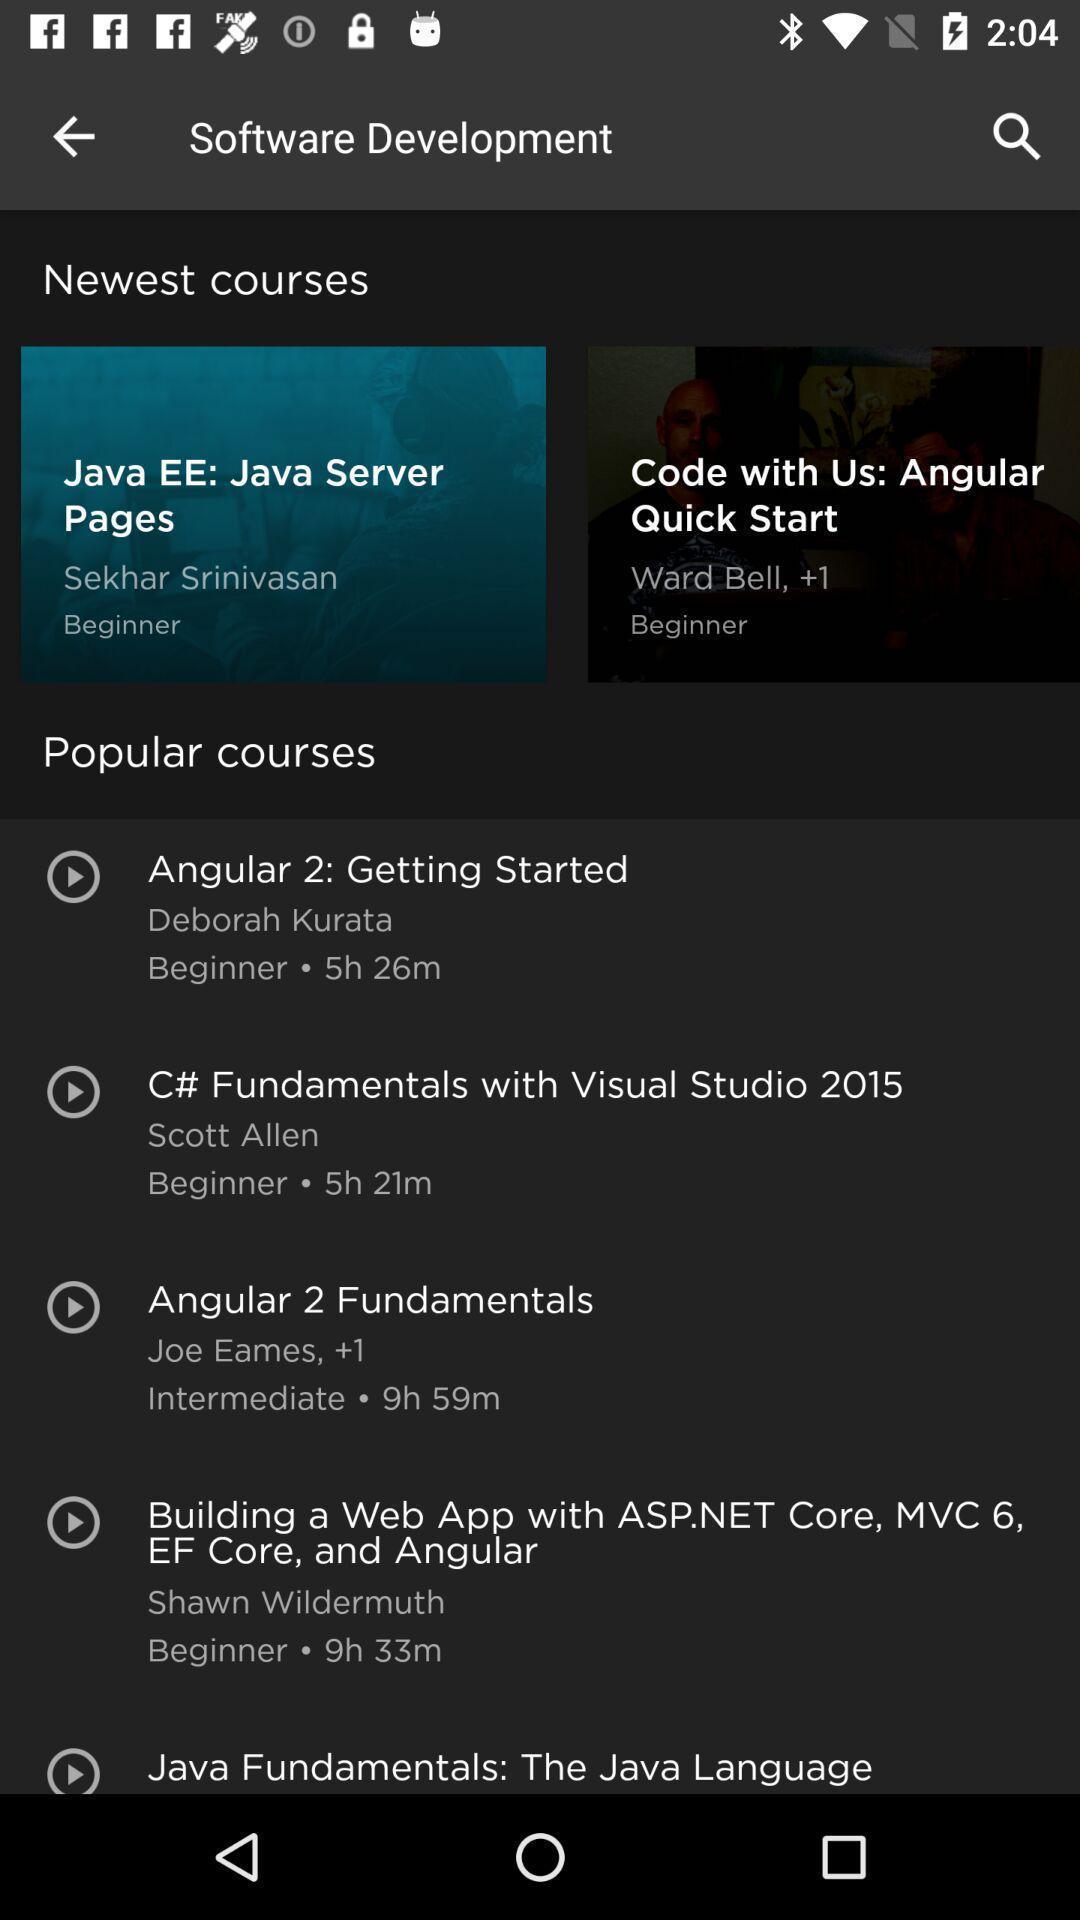What details can you identify in this image? Page displaying list of courses on a learning app. 